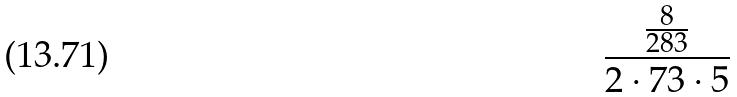<formula> <loc_0><loc_0><loc_500><loc_500>\frac { \frac { 8 } { 2 8 3 } } { 2 \cdot 7 3 \cdot 5 }</formula> 